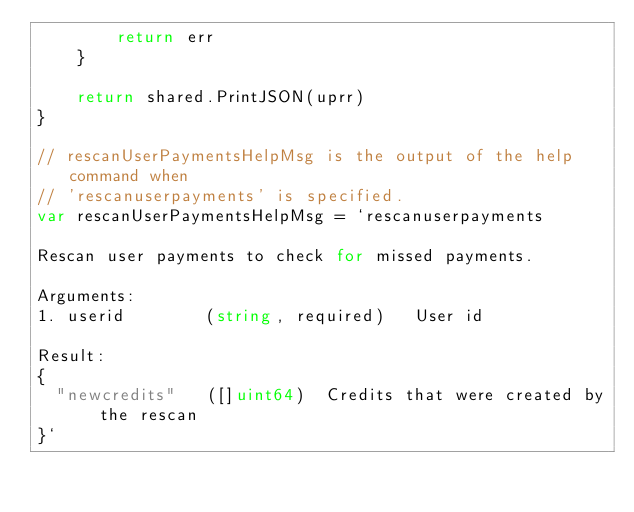<code> <loc_0><loc_0><loc_500><loc_500><_Go_>		return err
	}

	return shared.PrintJSON(uprr)
}

// rescanUserPaymentsHelpMsg is the output of the help command when
// 'rescanuserpayments' is specified.
var rescanUserPaymentsHelpMsg = `rescanuserpayments 

Rescan user payments to check for missed payments.

Arguments:
1. userid        (string, required)   User id 

Result:
{
  "newcredits"   ([]uint64)  Credits that were created by the rescan
}`
</code> 